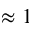Convert formula to latex. <formula><loc_0><loc_0><loc_500><loc_500>\approx 1</formula> 